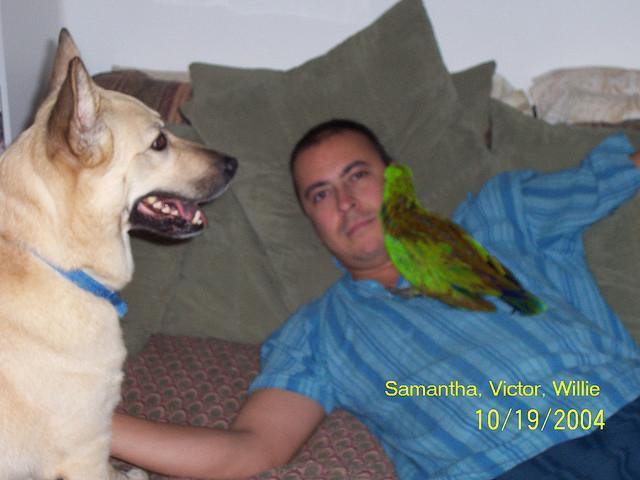How many animals are there?
Give a very brief answer. 2. How many bikes are on the floor?
Give a very brief answer. 0. 